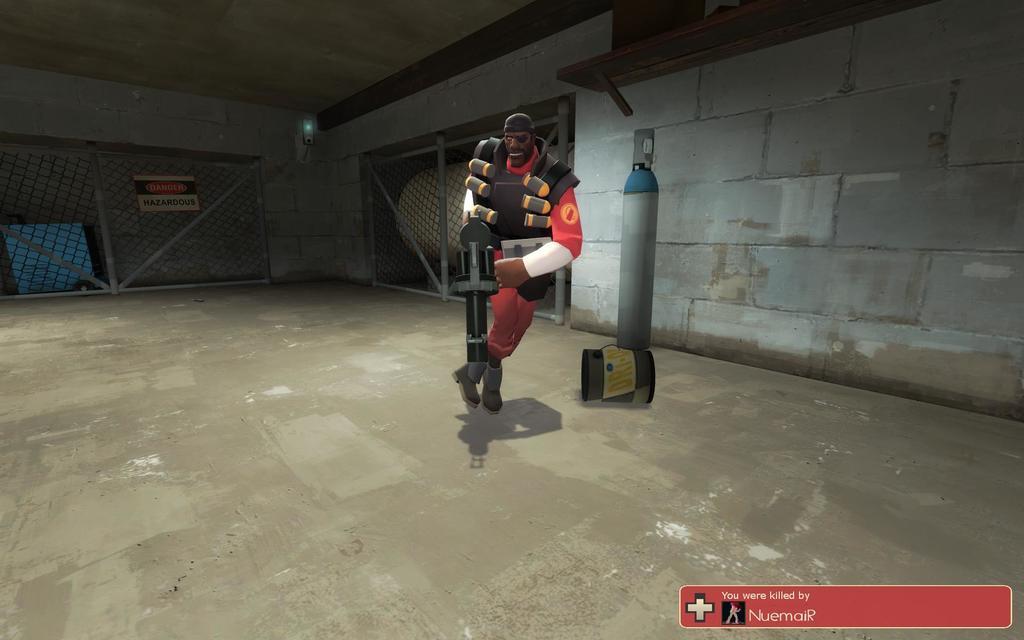Can you describe this image briefly? This is an animated image where we can see a person holding a weapon. Here we can see the wall, shelf, fence and caution board in the background. Here we can see the edited text. 